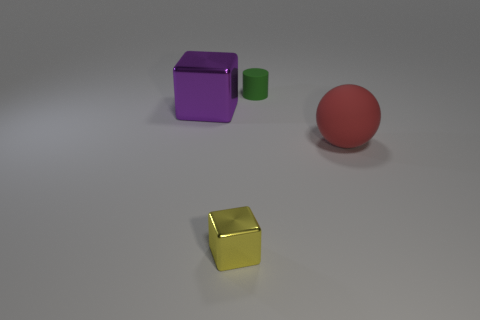Does the matte object that is in front of the small green rubber cylinder have the same size as the shiny cube in front of the large red sphere?
Offer a very short reply. No. There is a matte object to the left of the matte object in front of the large purple shiny thing; what shape is it?
Keep it short and to the point. Cylinder. How many tiny green matte things are right of the tiny cylinder?
Ensure brevity in your answer.  0. What is the color of the tiny cube that is made of the same material as the large block?
Give a very brief answer. Yellow. There is a cylinder; is its size the same as the metallic thing that is to the left of the small metal block?
Offer a very short reply. No. There is a shiny block in front of the metallic thing behind the rubber object that is in front of the small matte cylinder; what size is it?
Offer a very short reply. Small. How many metal objects are either green things or purple cubes?
Provide a short and direct response. 1. What color is the shiny thing on the left side of the yellow cube?
Provide a short and direct response. Purple. The other object that is the same size as the yellow metal object is what shape?
Offer a very short reply. Cylinder. There is a big metal thing; is its color the same as the cube that is in front of the big red matte ball?
Provide a succinct answer. No. 